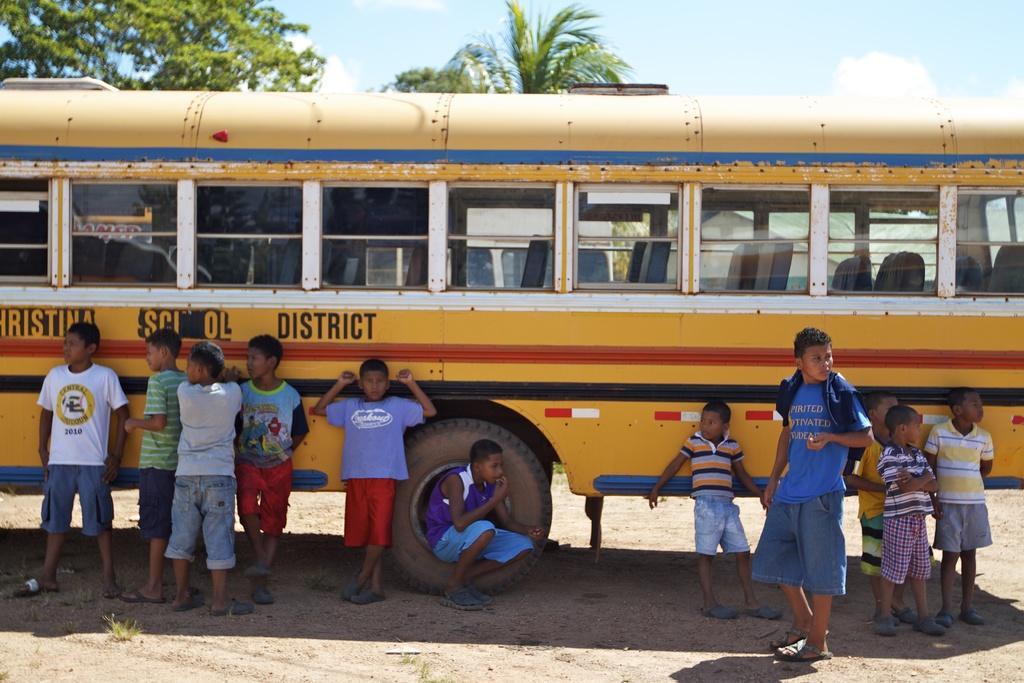In one or two sentences, can you explain what this image depicts? In this picture I see number of children in front who are on the sand and behind them I see a bus on which there is something written. In the background I see the sky and the trees. 